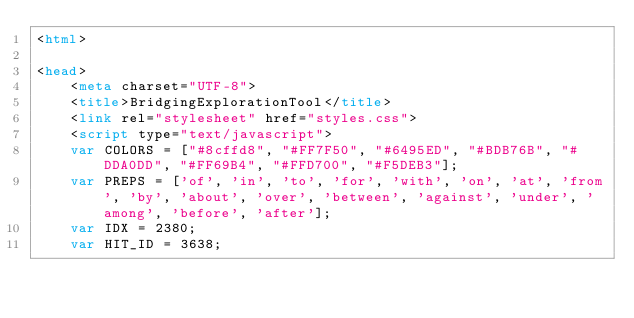Convert code to text. <code><loc_0><loc_0><loc_500><loc_500><_HTML_><html>

<head>
	<meta charset="UTF-8">
	<title>BridgingExplorationTool</title>
	<link rel="stylesheet" href="styles.css">
	<script type="text/javascript">
	var COLORS = ["#8cffd8", "#FF7F50", "#6495ED", "#BDB76B", "#DDA0DD", "#FF69B4", "#FFD700", "#F5DEB3"];
	var PREPS = ['of', 'in', 'to', 'for', 'with', 'on', 'at', 'from', 'by', 'about', 'over', 'between', 'against', 'under', 'among', 'before', 'after'];
	var IDX = 2380;
	var HIT_ID = 3638;</code> 